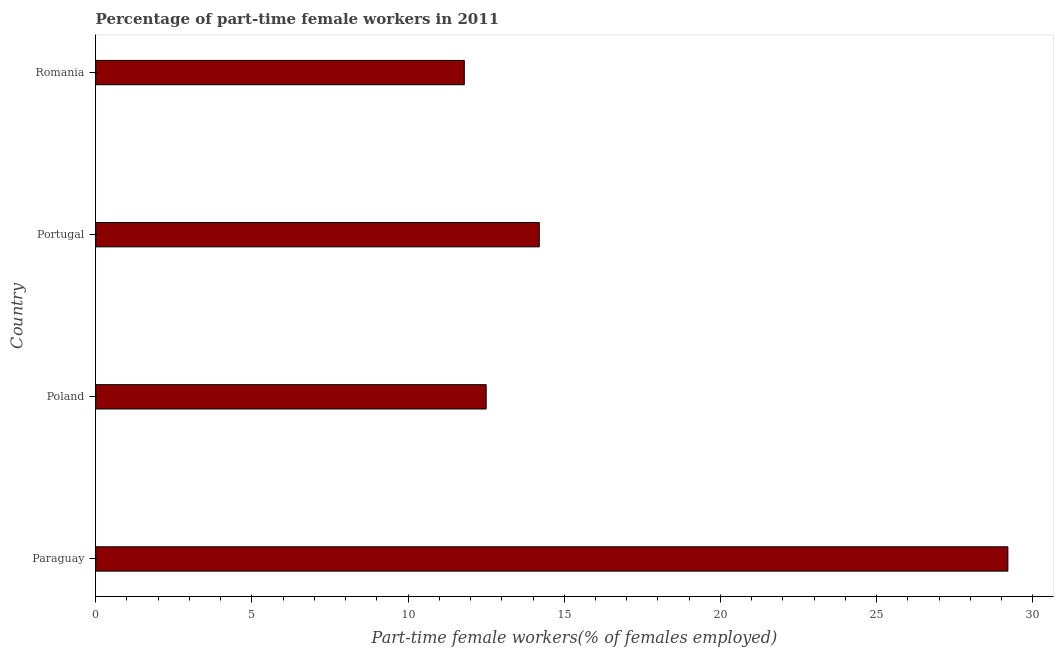Does the graph contain grids?
Give a very brief answer. No. What is the title of the graph?
Make the answer very short. Percentage of part-time female workers in 2011. What is the label or title of the X-axis?
Ensure brevity in your answer.  Part-time female workers(% of females employed). What is the label or title of the Y-axis?
Give a very brief answer. Country. Across all countries, what is the maximum percentage of part-time female workers?
Provide a short and direct response. 29.2. Across all countries, what is the minimum percentage of part-time female workers?
Keep it short and to the point. 11.8. In which country was the percentage of part-time female workers maximum?
Give a very brief answer. Paraguay. In which country was the percentage of part-time female workers minimum?
Provide a short and direct response. Romania. What is the sum of the percentage of part-time female workers?
Keep it short and to the point. 67.7. What is the difference between the percentage of part-time female workers in Paraguay and Romania?
Your answer should be compact. 17.4. What is the average percentage of part-time female workers per country?
Offer a terse response. 16.93. What is the median percentage of part-time female workers?
Your answer should be very brief. 13.35. What is the ratio of the percentage of part-time female workers in Poland to that in Romania?
Keep it short and to the point. 1.06. Is the percentage of part-time female workers in Poland less than that in Romania?
Ensure brevity in your answer.  No. Are all the bars in the graph horizontal?
Make the answer very short. Yes. How many countries are there in the graph?
Provide a succinct answer. 4. What is the difference between two consecutive major ticks on the X-axis?
Ensure brevity in your answer.  5. Are the values on the major ticks of X-axis written in scientific E-notation?
Keep it short and to the point. No. What is the Part-time female workers(% of females employed) in Paraguay?
Your answer should be compact. 29.2. What is the Part-time female workers(% of females employed) in Portugal?
Your answer should be compact. 14.2. What is the Part-time female workers(% of females employed) in Romania?
Give a very brief answer. 11.8. What is the difference between the Part-time female workers(% of females employed) in Paraguay and Poland?
Make the answer very short. 16.7. What is the difference between the Part-time female workers(% of females employed) in Poland and Portugal?
Offer a very short reply. -1.7. What is the difference between the Part-time female workers(% of females employed) in Portugal and Romania?
Make the answer very short. 2.4. What is the ratio of the Part-time female workers(% of females employed) in Paraguay to that in Poland?
Keep it short and to the point. 2.34. What is the ratio of the Part-time female workers(% of females employed) in Paraguay to that in Portugal?
Offer a terse response. 2.06. What is the ratio of the Part-time female workers(% of females employed) in Paraguay to that in Romania?
Give a very brief answer. 2.48. What is the ratio of the Part-time female workers(% of females employed) in Poland to that in Portugal?
Make the answer very short. 0.88. What is the ratio of the Part-time female workers(% of females employed) in Poland to that in Romania?
Make the answer very short. 1.06. What is the ratio of the Part-time female workers(% of females employed) in Portugal to that in Romania?
Ensure brevity in your answer.  1.2. 